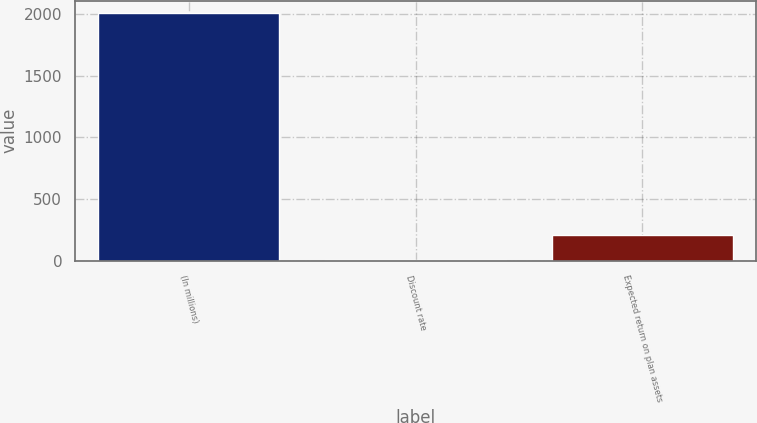Convert chart to OTSL. <chart><loc_0><loc_0><loc_500><loc_500><bar_chart><fcel>(In millions)<fcel>Discount rate<fcel>Expected return on plan assets<nl><fcel>2007<fcel>5.86<fcel>205.97<nl></chart> 